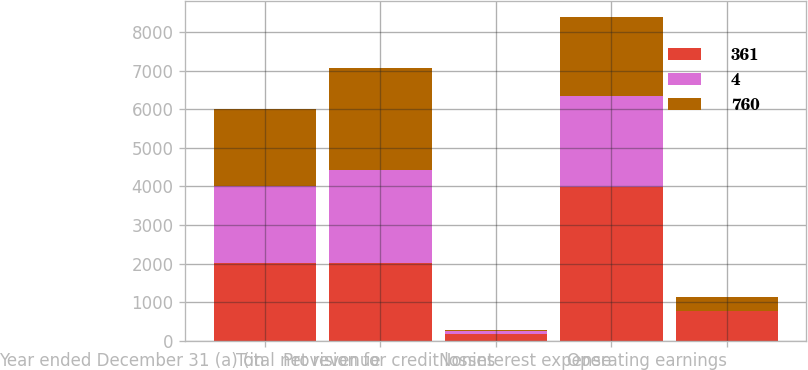Convert chart. <chart><loc_0><loc_0><loc_500><loc_500><stacked_bar_chart><ecel><fcel>Year ended December 31 (a) (in<fcel>Total net revenue<fcel>Provision for credit losses<fcel>Noninterest expense<fcel>Operating earnings<nl><fcel>361<fcel>2004<fcel>2002.5<fcel>165<fcel>3981<fcel>760<nl><fcel>4<fcel>2003<fcel>2422<fcel>76<fcel>2358<fcel>4<nl><fcel>760<fcel>2002<fcel>2648<fcel>31<fcel>2055<fcel>361<nl></chart> 